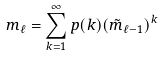Convert formula to latex. <formula><loc_0><loc_0><loc_500><loc_500>m _ { \ell } = \sum _ { k = 1 } ^ { \infty } p ( k ) ( \tilde { m } _ { \ell - 1 } ) ^ { k }</formula> 